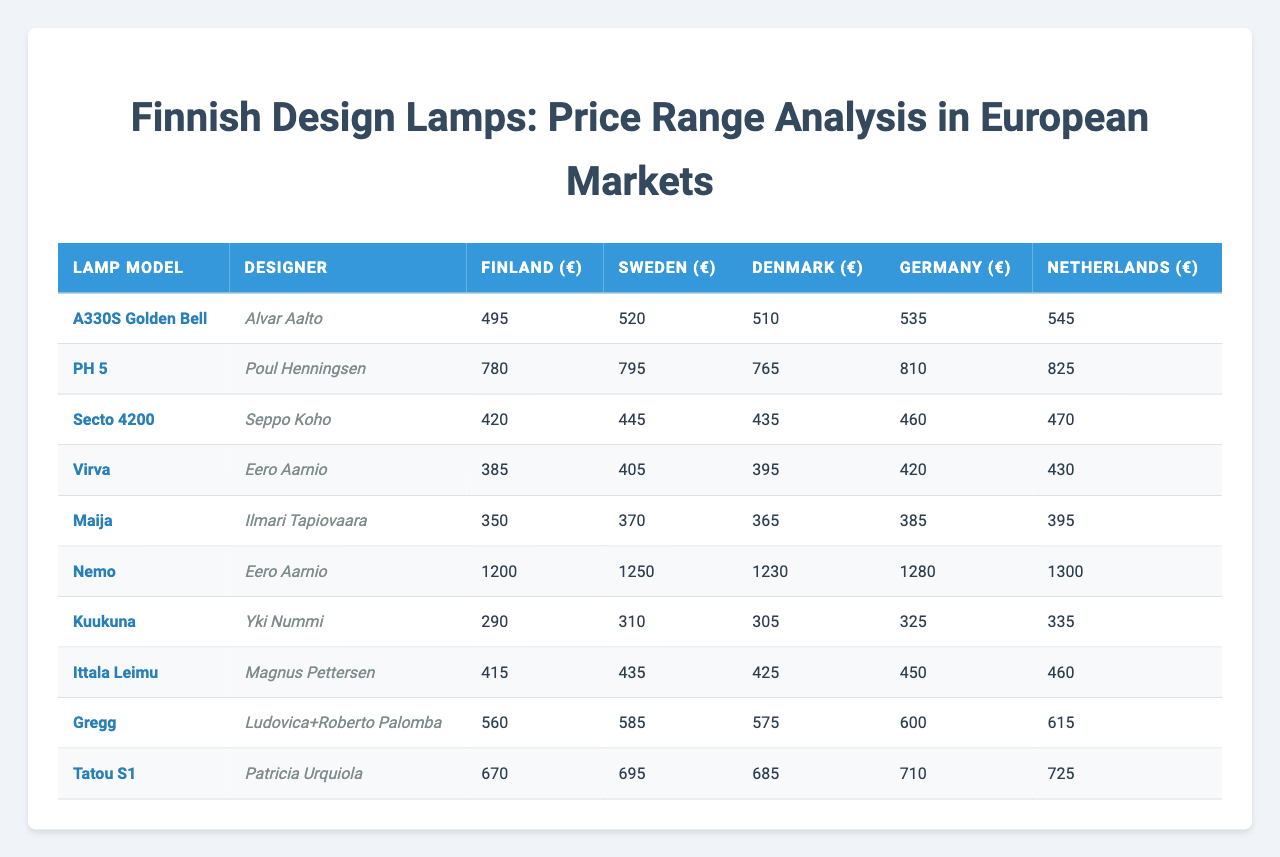What is the price of the "PH 5" lamp in Germany? The table lists the price of the "PH 5" lamp in Germany as €810.
Answer: €810 Which lamp model has the highest price in the Netherlands? According to the table, the lamp model "Nemo" is the most expensive in the Netherlands, priced at €1300.
Answer: Nemo What is the difference in price between "Virva" and "Maija" lamps in Finland? The price of "Virva" is €385 and the price of "Maija" is €350 in Finland. The difference is calculated as €385 - €350 = €35.
Answer: €35 Is the price of "Tatou S1" higher in Sweden than in Finland? The price of "Tatou S1" is €695 in Sweden and €670 in Finland, which means it is higher in Sweden.
Answer: Yes What is the average price of the lamps in Denmark? To find the average price in Denmark, sum the prices: 510 + 765 + 435 + 395 + 365 + 1230 + 305 + 425 + 575 + 685 = 4900. Then divide by the number of lamps (10): 4900 / 10 = 490.
Answer: €490 Which designer has the cheapest lamp model in Finland? By checking the prices, "Kuukuna" by Yki Nummi is the cheapest at €290 in Finland.
Answer: Yki Nummi If you sum the prices of all lamps in Germany, what is the total? Summing the prices of all lamps in Germany yields: 535 + 810 + 460 + 420 + 385 + 1280 + 325 + 450 + 600 + 710 =  4870.
Answer: €4870 What percentage more does the "Nemo" lamp cost compared to the "A330S Golden Bell" lamp in Finland? The price of the "Nemo" lamp is €1200 and the "A330S Golden Bell" lamp is €495. The difference is €1200 - €495 = €705. To calculate the percentage increase: (705 / 495) * 100 = approximately 142.4%.
Answer: 142.4% Which country has the lowest overall prices for the lamp "Secto 4200"? Looking at the prices, Sweden has the lowest price for the "Secto 4200" lamp at €445.
Answer: Sweden Is the "Ittala Leimu" lamp priced below €500 in Sweden? The price for "Ittala Leimu" in Sweden is €435, which is below €500.
Answer: Yes 